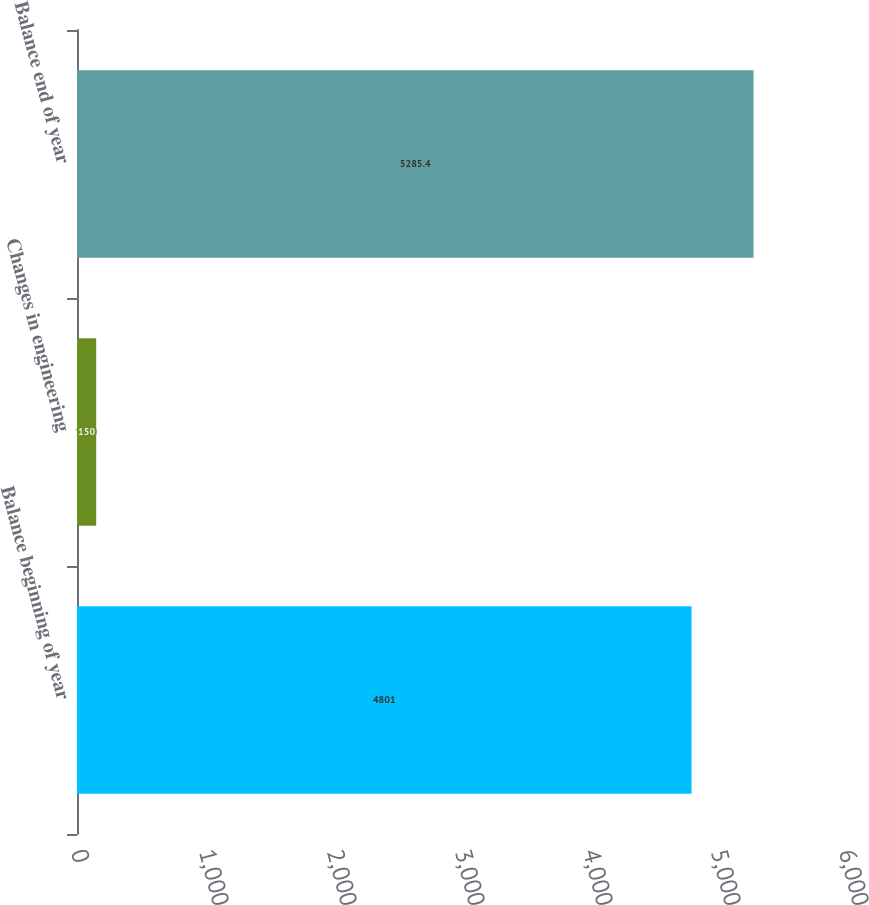Convert chart. <chart><loc_0><loc_0><loc_500><loc_500><bar_chart><fcel>Balance beginning of year<fcel>Changes in engineering<fcel>Balance end of year<nl><fcel>4801<fcel>150<fcel>5285.4<nl></chart> 